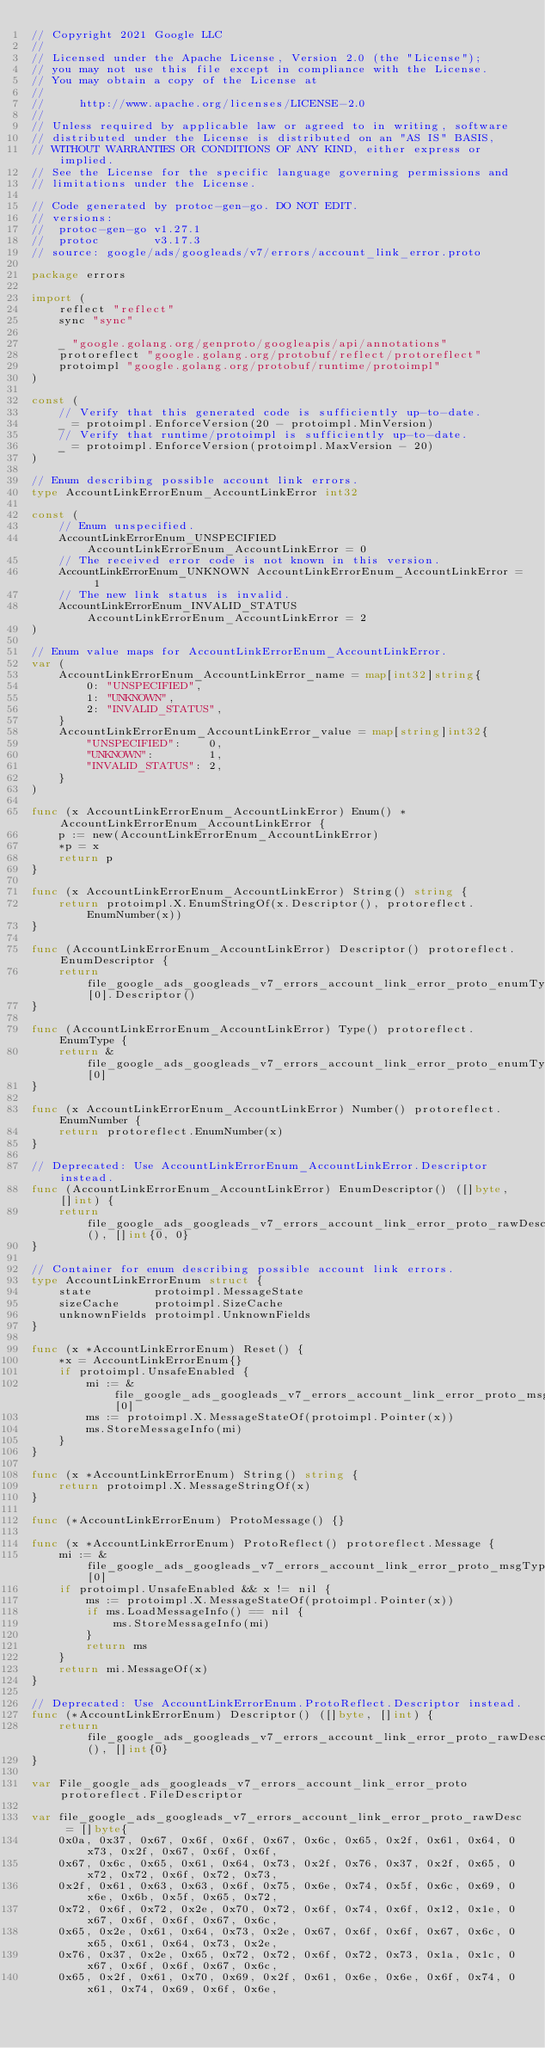<code> <loc_0><loc_0><loc_500><loc_500><_Go_>// Copyright 2021 Google LLC
//
// Licensed under the Apache License, Version 2.0 (the "License");
// you may not use this file except in compliance with the License.
// You may obtain a copy of the License at
//
//     http://www.apache.org/licenses/LICENSE-2.0
//
// Unless required by applicable law or agreed to in writing, software
// distributed under the License is distributed on an "AS IS" BASIS,
// WITHOUT WARRANTIES OR CONDITIONS OF ANY KIND, either express or implied.
// See the License for the specific language governing permissions and
// limitations under the License.

// Code generated by protoc-gen-go. DO NOT EDIT.
// versions:
// 	protoc-gen-go v1.27.1
// 	protoc        v3.17.3
// source: google/ads/googleads/v7/errors/account_link_error.proto

package errors

import (
	reflect "reflect"
	sync "sync"

	_ "google.golang.org/genproto/googleapis/api/annotations"
	protoreflect "google.golang.org/protobuf/reflect/protoreflect"
	protoimpl "google.golang.org/protobuf/runtime/protoimpl"
)

const (
	// Verify that this generated code is sufficiently up-to-date.
	_ = protoimpl.EnforceVersion(20 - protoimpl.MinVersion)
	// Verify that runtime/protoimpl is sufficiently up-to-date.
	_ = protoimpl.EnforceVersion(protoimpl.MaxVersion - 20)
)

// Enum describing possible account link errors.
type AccountLinkErrorEnum_AccountLinkError int32

const (
	// Enum unspecified.
	AccountLinkErrorEnum_UNSPECIFIED AccountLinkErrorEnum_AccountLinkError = 0
	// The received error code is not known in this version.
	AccountLinkErrorEnum_UNKNOWN AccountLinkErrorEnum_AccountLinkError = 1
	// The new link status is invalid.
	AccountLinkErrorEnum_INVALID_STATUS AccountLinkErrorEnum_AccountLinkError = 2
)

// Enum value maps for AccountLinkErrorEnum_AccountLinkError.
var (
	AccountLinkErrorEnum_AccountLinkError_name = map[int32]string{
		0: "UNSPECIFIED",
		1: "UNKNOWN",
		2: "INVALID_STATUS",
	}
	AccountLinkErrorEnum_AccountLinkError_value = map[string]int32{
		"UNSPECIFIED":    0,
		"UNKNOWN":        1,
		"INVALID_STATUS": 2,
	}
)

func (x AccountLinkErrorEnum_AccountLinkError) Enum() *AccountLinkErrorEnum_AccountLinkError {
	p := new(AccountLinkErrorEnum_AccountLinkError)
	*p = x
	return p
}

func (x AccountLinkErrorEnum_AccountLinkError) String() string {
	return protoimpl.X.EnumStringOf(x.Descriptor(), protoreflect.EnumNumber(x))
}

func (AccountLinkErrorEnum_AccountLinkError) Descriptor() protoreflect.EnumDescriptor {
	return file_google_ads_googleads_v7_errors_account_link_error_proto_enumTypes[0].Descriptor()
}

func (AccountLinkErrorEnum_AccountLinkError) Type() protoreflect.EnumType {
	return &file_google_ads_googleads_v7_errors_account_link_error_proto_enumTypes[0]
}

func (x AccountLinkErrorEnum_AccountLinkError) Number() protoreflect.EnumNumber {
	return protoreflect.EnumNumber(x)
}

// Deprecated: Use AccountLinkErrorEnum_AccountLinkError.Descriptor instead.
func (AccountLinkErrorEnum_AccountLinkError) EnumDescriptor() ([]byte, []int) {
	return file_google_ads_googleads_v7_errors_account_link_error_proto_rawDescGZIP(), []int{0, 0}
}

// Container for enum describing possible account link errors.
type AccountLinkErrorEnum struct {
	state         protoimpl.MessageState
	sizeCache     protoimpl.SizeCache
	unknownFields protoimpl.UnknownFields
}

func (x *AccountLinkErrorEnum) Reset() {
	*x = AccountLinkErrorEnum{}
	if protoimpl.UnsafeEnabled {
		mi := &file_google_ads_googleads_v7_errors_account_link_error_proto_msgTypes[0]
		ms := protoimpl.X.MessageStateOf(protoimpl.Pointer(x))
		ms.StoreMessageInfo(mi)
	}
}

func (x *AccountLinkErrorEnum) String() string {
	return protoimpl.X.MessageStringOf(x)
}

func (*AccountLinkErrorEnum) ProtoMessage() {}

func (x *AccountLinkErrorEnum) ProtoReflect() protoreflect.Message {
	mi := &file_google_ads_googleads_v7_errors_account_link_error_proto_msgTypes[0]
	if protoimpl.UnsafeEnabled && x != nil {
		ms := protoimpl.X.MessageStateOf(protoimpl.Pointer(x))
		if ms.LoadMessageInfo() == nil {
			ms.StoreMessageInfo(mi)
		}
		return ms
	}
	return mi.MessageOf(x)
}

// Deprecated: Use AccountLinkErrorEnum.ProtoReflect.Descriptor instead.
func (*AccountLinkErrorEnum) Descriptor() ([]byte, []int) {
	return file_google_ads_googleads_v7_errors_account_link_error_proto_rawDescGZIP(), []int{0}
}

var File_google_ads_googleads_v7_errors_account_link_error_proto protoreflect.FileDescriptor

var file_google_ads_googleads_v7_errors_account_link_error_proto_rawDesc = []byte{
	0x0a, 0x37, 0x67, 0x6f, 0x6f, 0x67, 0x6c, 0x65, 0x2f, 0x61, 0x64, 0x73, 0x2f, 0x67, 0x6f, 0x6f,
	0x67, 0x6c, 0x65, 0x61, 0x64, 0x73, 0x2f, 0x76, 0x37, 0x2f, 0x65, 0x72, 0x72, 0x6f, 0x72, 0x73,
	0x2f, 0x61, 0x63, 0x63, 0x6f, 0x75, 0x6e, 0x74, 0x5f, 0x6c, 0x69, 0x6e, 0x6b, 0x5f, 0x65, 0x72,
	0x72, 0x6f, 0x72, 0x2e, 0x70, 0x72, 0x6f, 0x74, 0x6f, 0x12, 0x1e, 0x67, 0x6f, 0x6f, 0x67, 0x6c,
	0x65, 0x2e, 0x61, 0x64, 0x73, 0x2e, 0x67, 0x6f, 0x6f, 0x67, 0x6c, 0x65, 0x61, 0x64, 0x73, 0x2e,
	0x76, 0x37, 0x2e, 0x65, 0x72, 0x72, 0x6f, 0x72, 0x73, 0x1a, 0x1c, 0x67, 0x6f, 0x6f, 0x67, 0x6c,
	0x65, 0x2f, 0x61, 0x70, 0x69, 0x2f, 0x61, 0x6e, 0x6e, 0x6f, 0x74, 0x61, 0x74, 0x69, 0x6f, 0x6e,</code> 